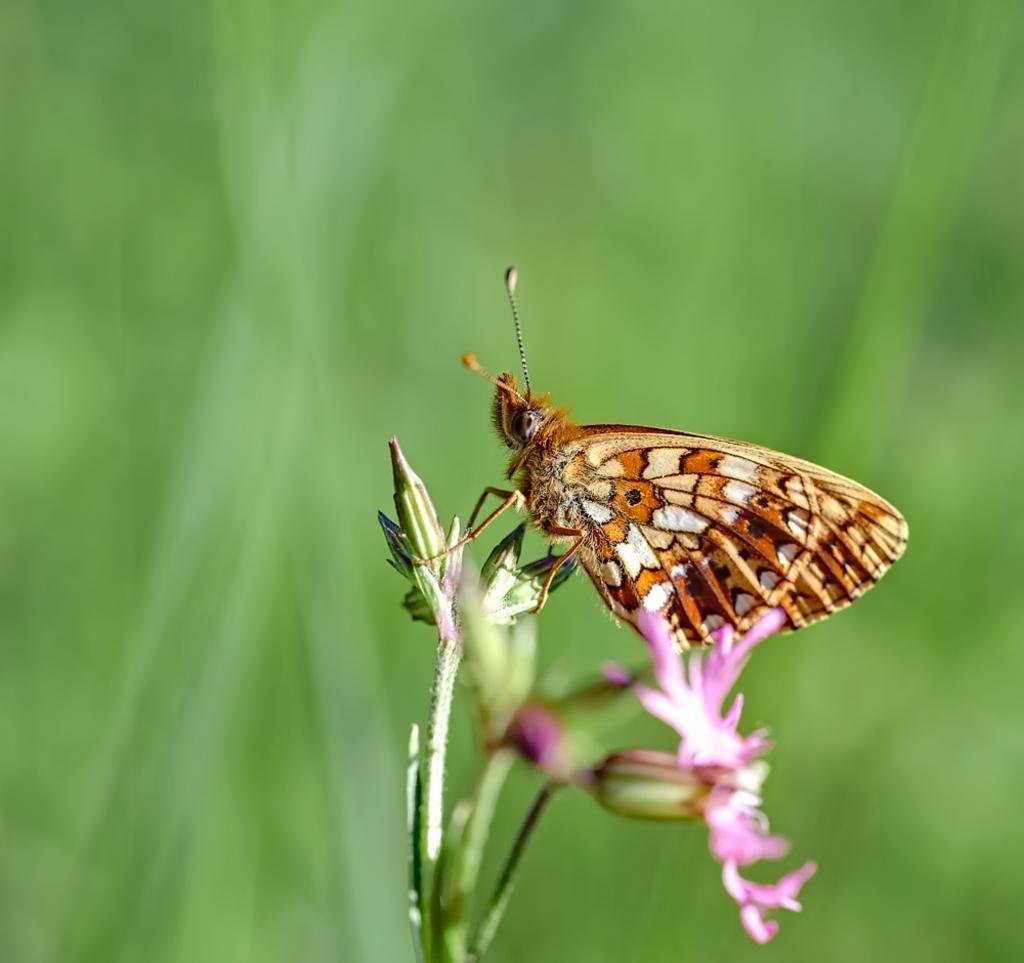Please provide a concise description of this image. In the picture I can see a butterfly is sitting on flowers. The background of the image is blurred. 